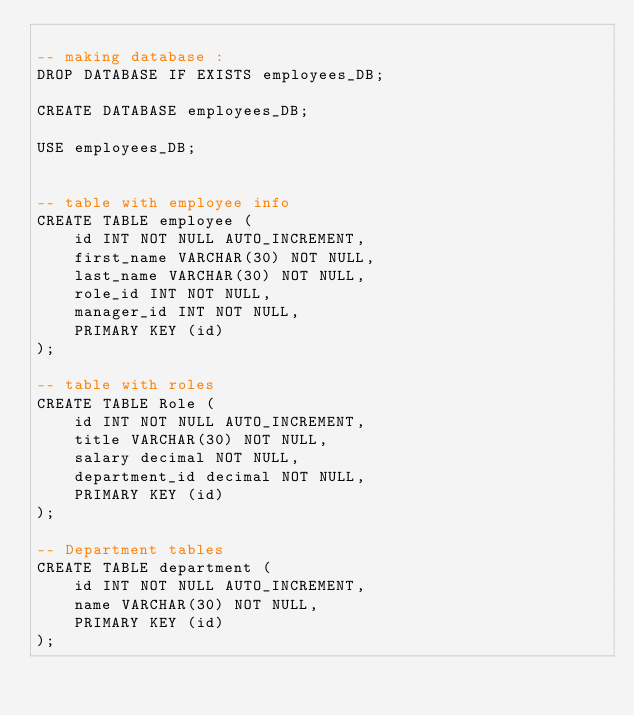Convert code to text. <code><loc_0><loc_0><loc_500><loc_500><_SQL_>
-- making database :
DROP DATABASE IF EXISTS employees_DB;

CREATE DATABASE employees_DB;

USE employees_DB;


-- table with employee info
CREATE TABLE employee (
    id INT NOT NULL AUTO_INCREMENT,
    first_name VARCHAR(30) NOT NULL,
    last_name VARCHAR(30) NOT NULL,
    role_id INT NOT NULL,
    manager_id INT NOT NULL,
    PRIMARY KEY (id)
);

-- table with roles 
CREATE TABLE Role (
    id INT NOT NULL AUTO_INCREMENT,
    title VARCHAR(30) NOT NULL,
    salary decimal NOT NULL,
    department_id decimal NOT NULL,
    PRIMARY KEY (id)
);

-- Department tables
CREATE TABLE department (
    id INT NOT NULL AUTO_INCREMENT,
    name VARCHAR(30) NOT NULL,
    PRIMARY KEY (id)
);
</code> 